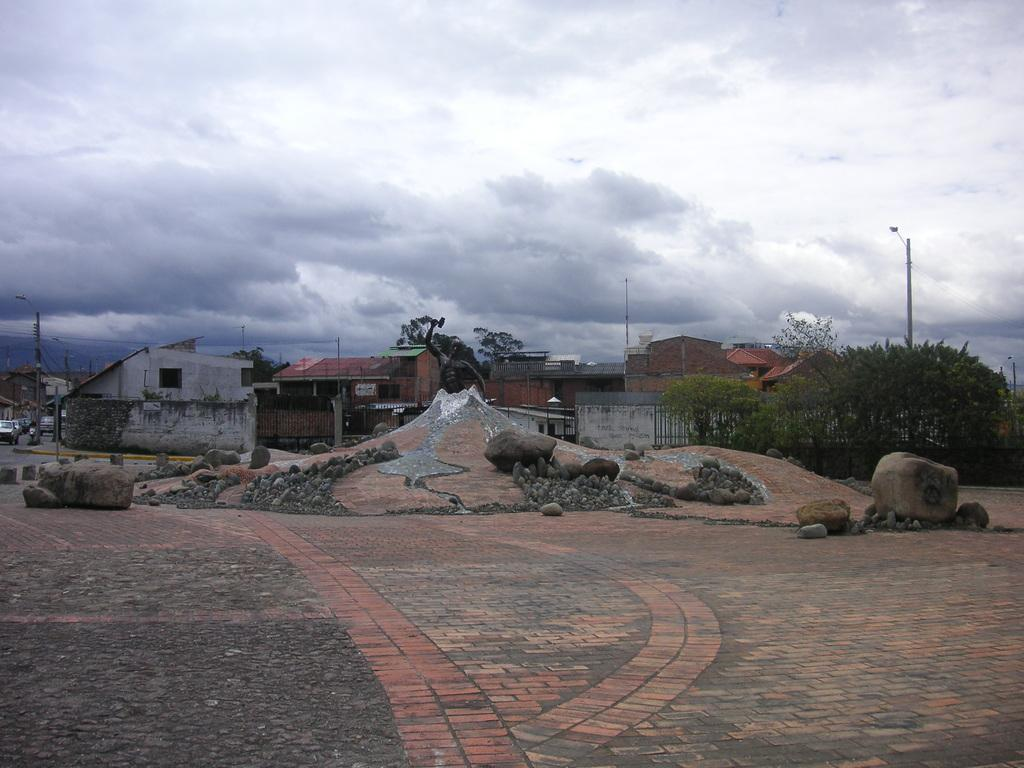What type of structures can be seen in the image? There are many houses in the image. What other elements can be found in the image besides houses? There are stones, a footpath, trees, and poles in the image. What is the condition of the sky in the image? The sky is cloudy in the image. Can you tell me how many friends are walking along the footpath in the image? There are no friends or people walking along the footpath in the image; it only shows houses, stones, a footpath, trees, poles, and a cloudy sky. 